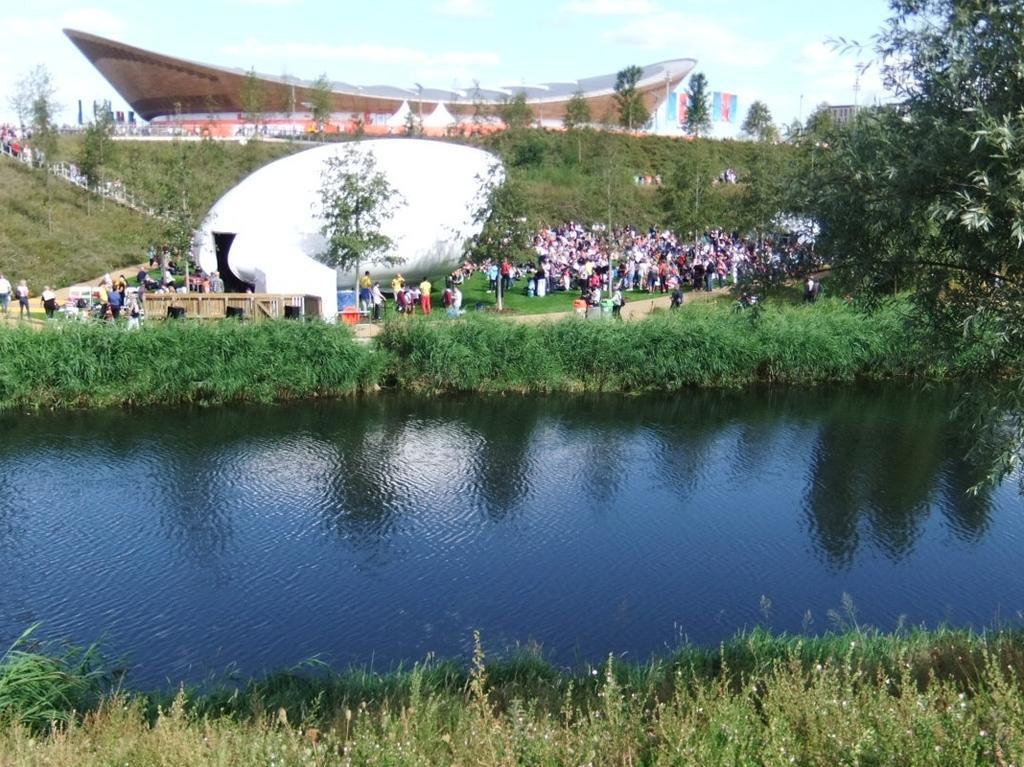In one or two sentences, can you explain what this image depicts? In this image, we can see some trees and persons. There is a lake in between plants. There are architectures in the middle of the image. There is a sky at the top of the image. 